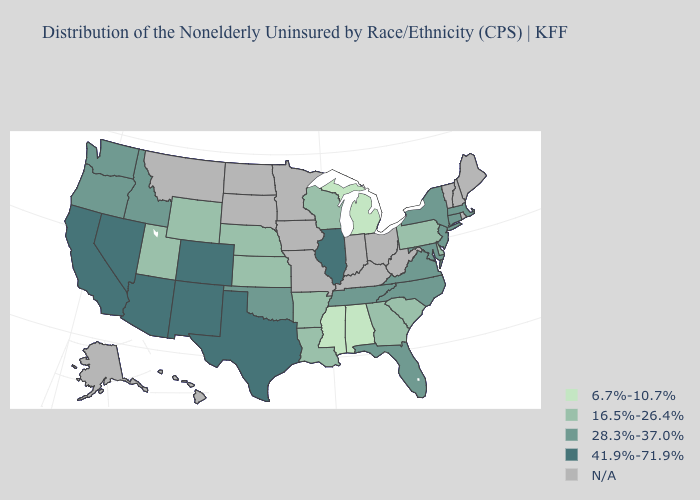What is the value of Ohio?
Quick response, please. N/A. Does Illinois have the highest value in the USA?
Quick response, please. Yes. What is the highest value in the MidWest ?
Answer briefly. 41.9%-71.9%. Name the states that have a value in the range 6.7%-10.7%?
Write a very short answer. Alabama, Michigan, Mississippi. Which states have the lowest value in the USA?
Concise answer only. Alabama, Michigan, Mississippi. What is the highest value in states that border California?
Be succinct. 41.9%-71.9%. Among the states that border North Carolina , does South Carolina have the highest value?
Short answer required. No. Does Pennsylvania have the highest value in the Northeast?
Answer briefly. No. Which states have the highest value in the USA?
Keep it brief. Arizona, California, Colorado, Illinois, Nevada, New Mexico, Texas. What is the value of Connecticut?
Give a very brief answer. 28.3%-37.0%. Which states hav the highest value in the Northeast?
Keep it brief. Connecticut, Massachusetts, New Jersey, New York. Name the states that have a value in the range 28.3%-37.0%?
Be succinct. Connecticut, Florida, Idaho, Maryland, Massachusetts, New Jersey, New York, North Carolina, Oklahoma, Oregon, Tennessee, Virginia, Washington. What is the value of Texas?
Quick response, please. 41.9%-71.9%. Does New Mexico have the highest value in the USA?
Be succinct. Yes. 